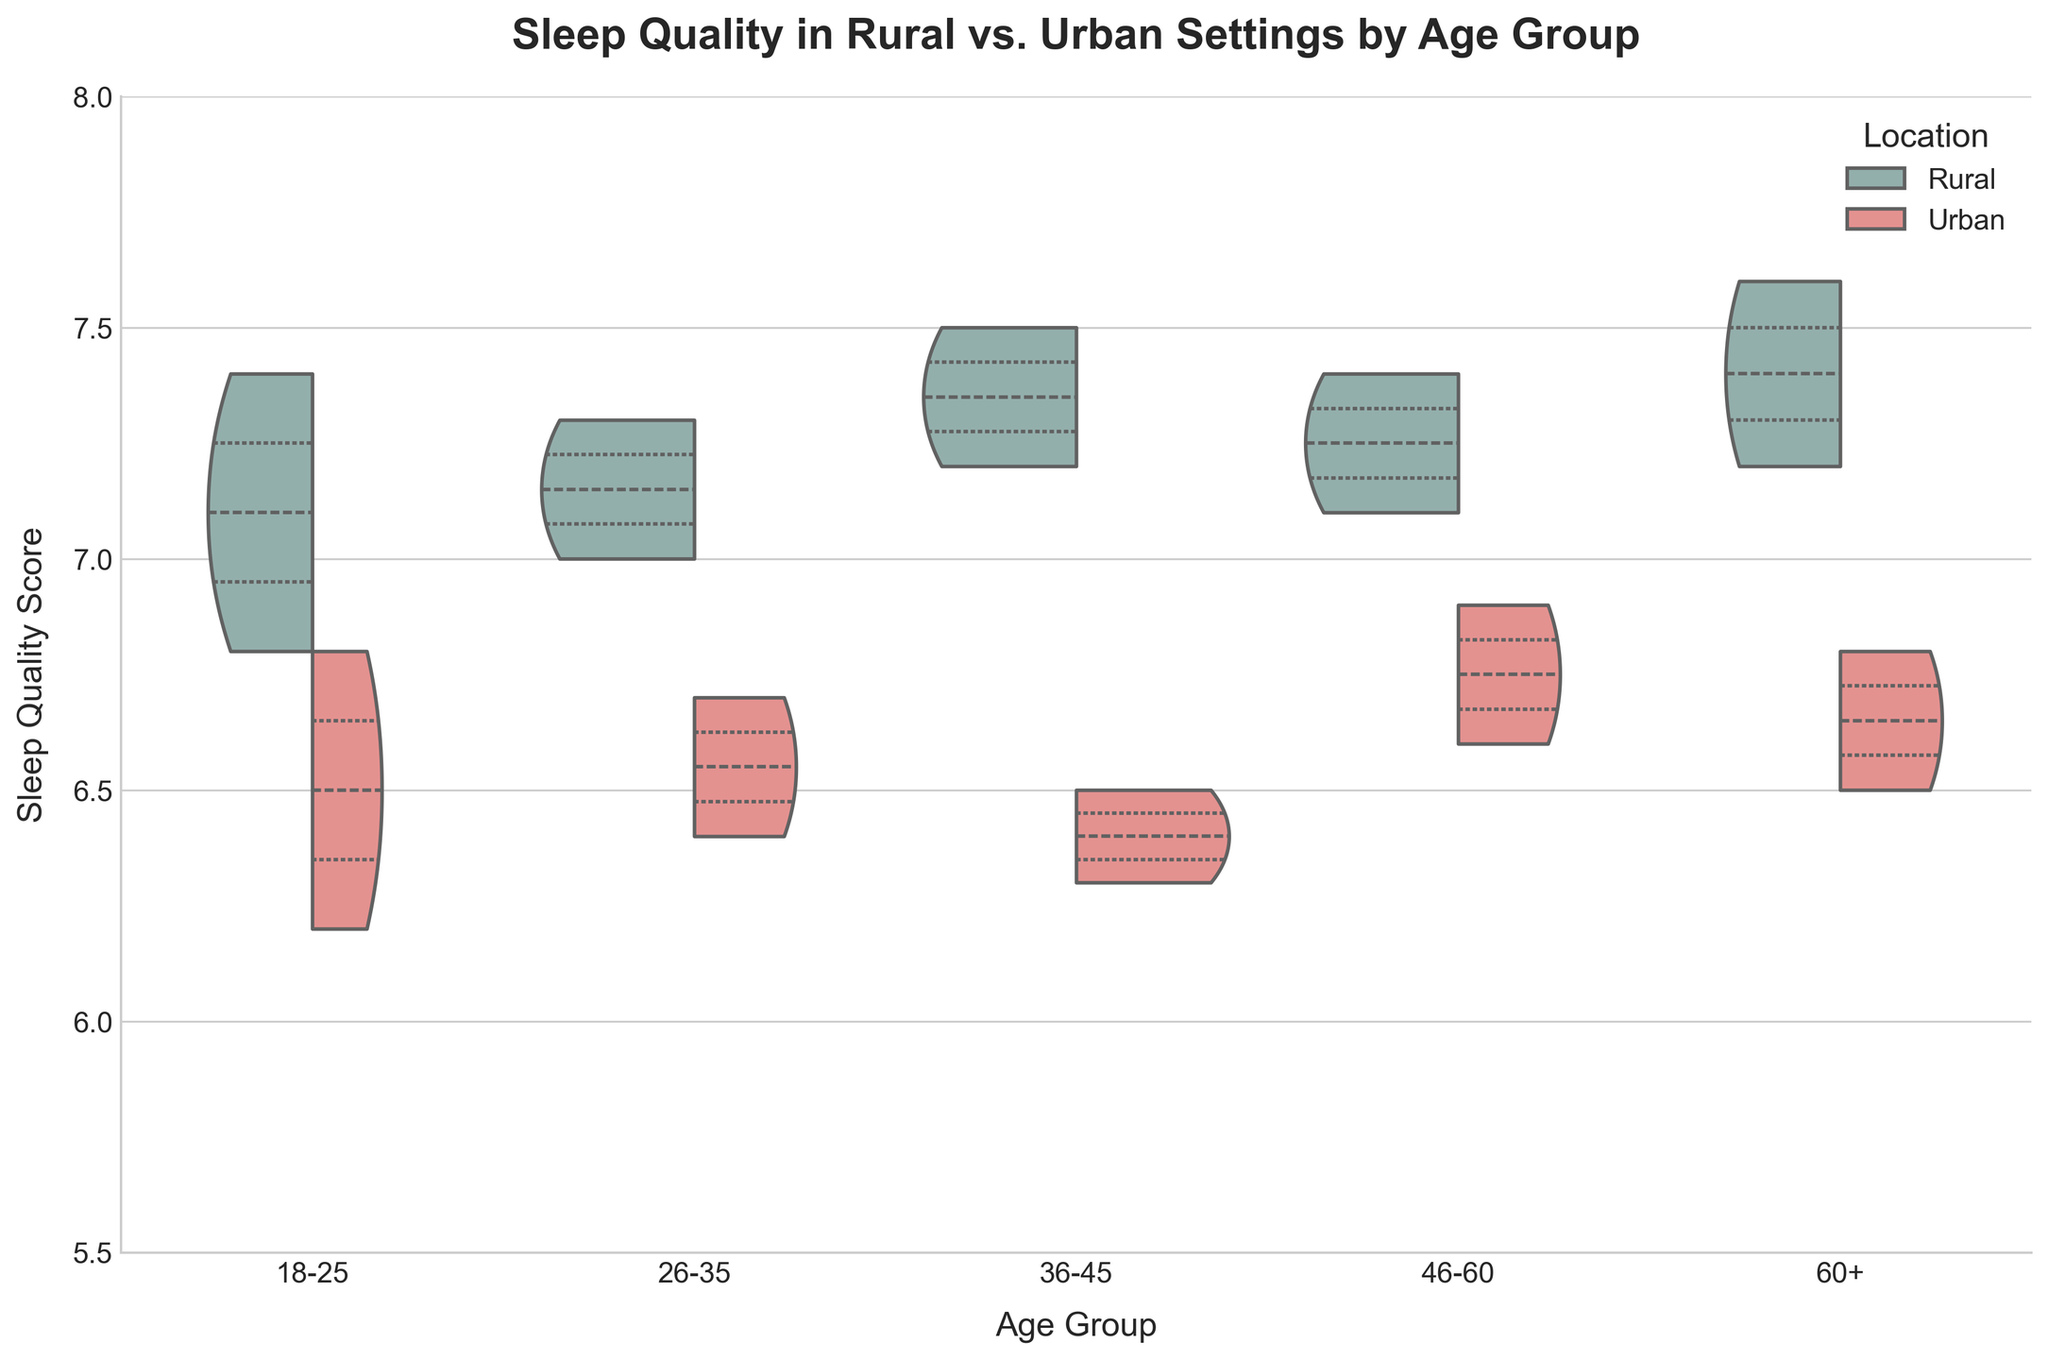What's the title of the figure? The title of the figure is positioned at the top center of the chart.
Answer: Sleep Quality in Rural vs. Urban Settings by Age Group What are the age groups represented on the x-axis? The x-axis shows different age groups which are labeled below the axis.
Answer: 18-25, 26-35, 36-45, 46-60, 60+ What is the average sleep quality for the rural 18-25 age group? The sleep quality data shown in the figure for the rural 18-25 age group is 7.1, 6.8, and 7.4. The sum is 7.1 + 6.8 + 7.4 = 21.3. Therefore, the average is 21.3 / 3 = 7.1
Answer: 7.1 How do the median sleep quality values compare between rural and urban settings for the 46-60 age group? By checking the quartile markers within the violin plot for the 46-60 age group, the median in rural settings is higher compared to urban settings.
Answer: Rural median is higher than urban What color represents urban settings in the violin plot? The violin plot uses distinct colors for different settings. The urban settings are represented by a shade of red.
Answer: Red Which age group shows the smallest difference in median sleep quality between rural and urban settings? By comparing the quartile markers of each age group, the 18-25 age group shows the smallest difference in median sleep quality between rural and urban settings.
Answer: 18-25 Which setting generally shows higher sleep quality across all age groups? Observing the overall distribution and quartile markers, rural settings consistently show higher sleep quality across all age groups.
Answer: Rural For the 60+ age group, what is the range of sleep quality values in rural settings? In the rural settings for the 60+ age group, the sleep quality values are 7.6 and 7.2. The range is the difference between the maximum and minimum values, so 7.6 - 7.2 = 0.4
Answer: 0.4 How do the distributions' shapes differ between rural and urban settings for the 36-45 age group? By looking at the shapes of the violin plots, rural settings show a more symmetrical and narrower distribution, while urban settings are more spread out.
Answer: Rural is narrower and more symmetrical, Urban is more spread out What is the maximum sleep quality value observed in urban settings? Observing the maximum points within the urban sections of each violin plot, the highest sleep quality value in urban settings is 6.9.
Answer: 6.9 